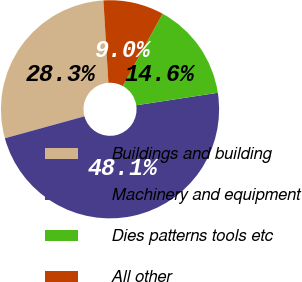Convert chart to OTSL. <chart><loc_0><loc_0><loc_500><loc_500><pie_chart><fcel>Buildings and building<fcel>Machinery and equipment<fcel>Dies patterns tools etc<fcel>All other<nl><fcel>28.31%<fcel>48.14%<fcel>14.57%<fcel>8.97%<nl></chart> 